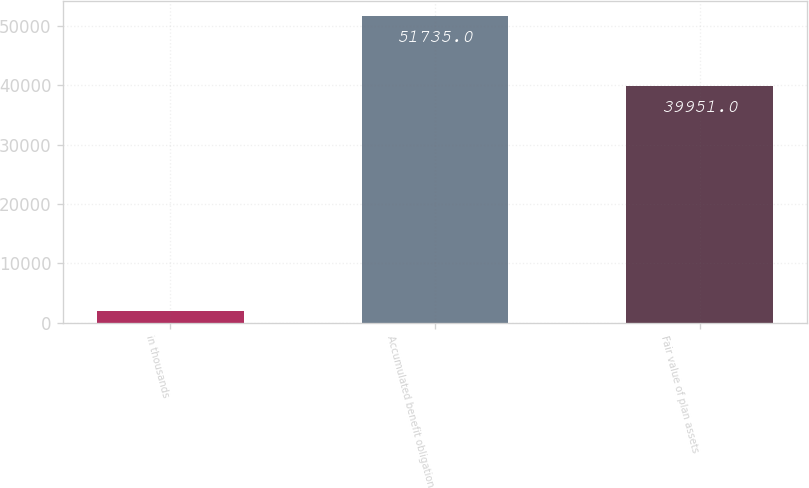Convert chart. <chart><loc_0><loc_0><loc_500><loc_500><bar_chart><fcel>In thousands<fcel>Accumulated benefit obligation<fcel>Fair value of plan assets<nl><fcel>2011<fcel>51735<fcel>39951<nl></chart> 